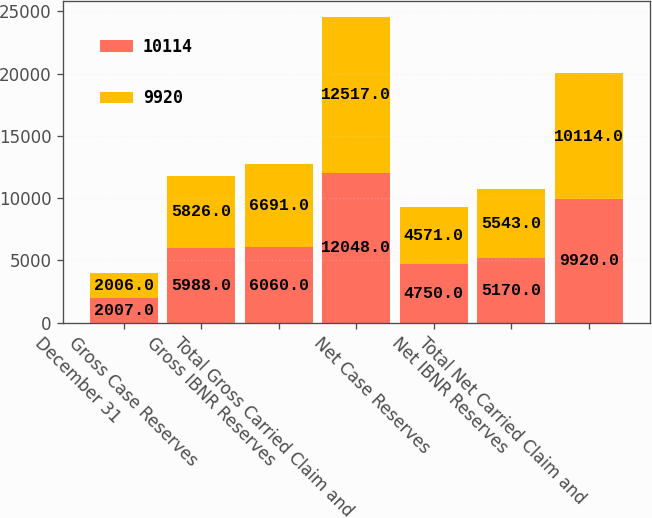Convert chart. <chart><loc_0><loc_0><loc_500><loc_500><stacked_bar_chart><ecel><fcel>December 31<fcel>Gross Case Reserves<fcel>Gross IBNR Reserves<fcel>Total Gross Carried Claim and<fcel>Net Case Reserves<fcel>Net IBNR Reserves<fcel>Total Net Carried Claim and<nl><fcel>10114<fcel>2007<fcel>5988<fcel>6060<fcel>12048<fcel>4750<fcel>5170<fcel>9920<nl><fcel>9920<fcel>2006<fcel>5826<fcel>6691<fcel>12517<fcel>4571<fcel>5543<fcel>10114<nl></chart> 